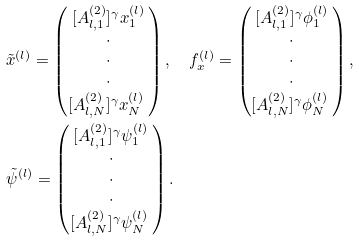Convert formula to latex. <formula><loc_0><loc_0><loc_500><loc_500>& \tilde { x } ^ { ( l ) } = \begin{pmatrix} [ A _ { l , 1 } ^ { ( 2 ) } ] ^ { \gamma } x _ { 1 } ^ { ( l ) } \\ \cdot \\ \cdot \\ \cdot \\ [ A _ { l , N } ^ { ( 2 ) } ] ^ { \gamma } x _ { N } ^ { ( l ) } \ \end{pmatrix} , \quad f _ { x } ^ { ( l ) } = \begin{pmatrix} [ A _ { l , 1 } ^ { ( 2 ) } ] ^ { \gamma } \phi _ { 1 } ^ { ( l ) } \\ \cdot \\ \cdot \\ \cdot \\ [ A _ { l , N } ^ { ( 2 ) } ] ^ { \gamma } \phi _ { N } ^ { ( l ) } \ \end{pmatrix} , \\ & \tilde { \psi } ^ { ( l ) } = \begin{pmatrix} [ A _ { l , 1 } ^ { ( 2 ) } ] ^ { \gamma } \psi _ { 1 } ^ { ( l ) } \\ \cdot \\ \cdot \\ \cdot \\ [ A _ { l , N } ^ { ( 2 ) } ] ^ { \gamma } \psi _ { N } ^ { ( l ) } \ \end{pmatrix} .</formula> 